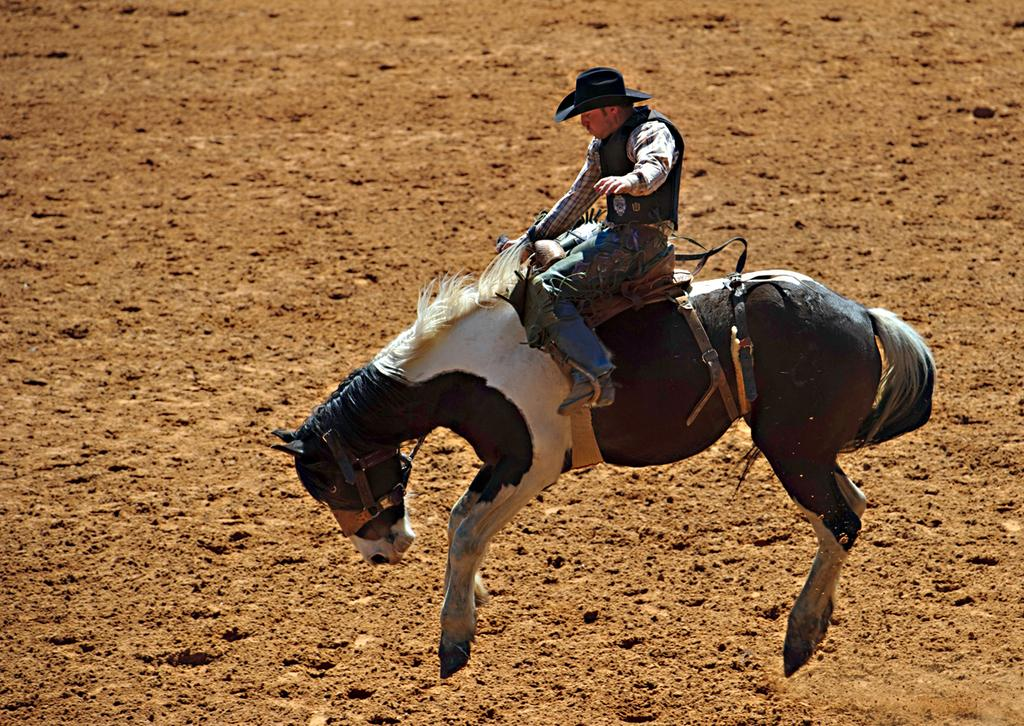What is happening in the image? There is a person in the image, and they are riding a horse. Where is the horse and rider located? The horse and rider are on the ground. What type of chain can be seen connecting the horse and rider in the image? There is no chain connecting the horse and rider in the image. What kind of arch is visible in the background of the image? There is no arch visible in the background of the image. 